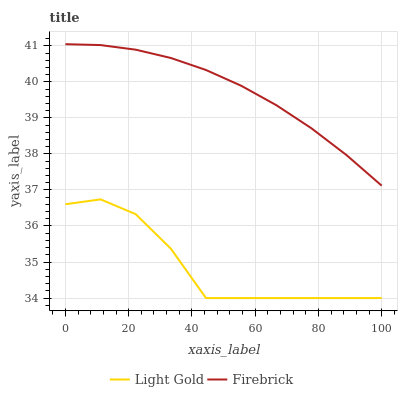Does Light Gold have the minimum area under the curve?
Answer yes or no. Yes. Does Firebrick have the maximum area under the curve?
Answer yes or no. Yes. Does Light Gold have the maximum area under the curve?
Answer yes or no. No. Is Firebrick the smoothest?
Answer yes or no. Yes. Is Light Gold the roughest?
Answer yes or no. Yes. Is Light Gold the smoothest?
Answer yes or no. No. Does Firebrick have the highest value?
Answer yes or no. Yes. Does Light Gold have the highest value?
Answer yes or no. No. Is Light Gold less than Firebrick?
Answer yes or no. Yes. Is Firebrick greater than Light Gold?
Answer yes or no. Yes. Does Light Gold intersect Firebrick?
Answer yes or no. No. 